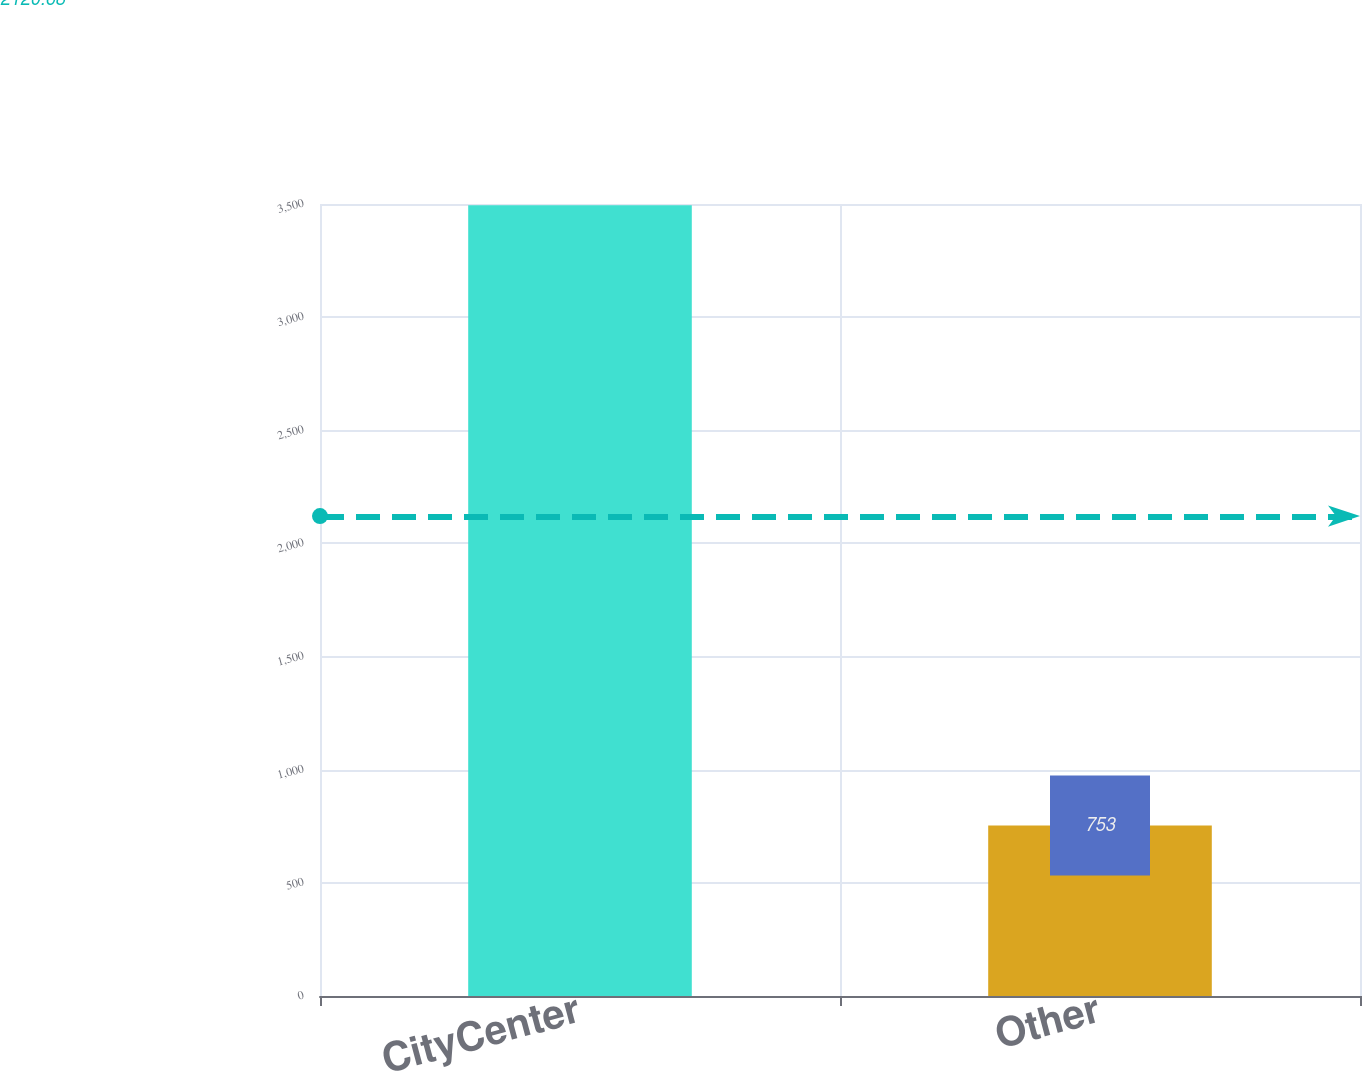Convert chart to OTSL. <chart><loc_0><loc_0><loc_500><loc_500><bar_chart><fcel>CityCenter<fcel>Other<nl><fcel>3494<fcel>753<nl></chart> 